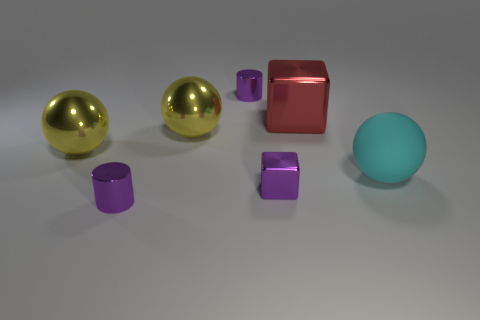What number of objects are small objects in front of the large block or objects left of the large red thing?
Your answer should be very brief. 5. What size is the purple thing that is on the left side of the tiny cube and in front of the big rubber sphere?
Keep it short and to the point. Small. Do the big red object and the small metal object that is in front of the purple shiny block have the same shape?
Offer a very short reply. No. What number of objects are either purple metal objects in front of the cyan matte object or big cyan things?
Offer a very short reply. 3. Is the material of the cyan sphere the same as the block behind the tiny metallic block?
Your answer should be compact. No. There is a small purple metal thing that is on the left side of the tiny purple cylinder that is behind the rubber thing; what shape is it?
Provide a succinct answer. Cylinder. There is a small cube; is it the same color as the small cylinder behind the large cyan thing?
Your answer should be very brief. Yes. Is there anything else that has the same material as the big cyan thing?
Your answer should be very brief. No. There is a red object; what shape is it?
Your answer should be compact. Cube. How big is the sphere to the right of the purple metal thing that is behind the purple cube?
Offer a terse response. Large. 